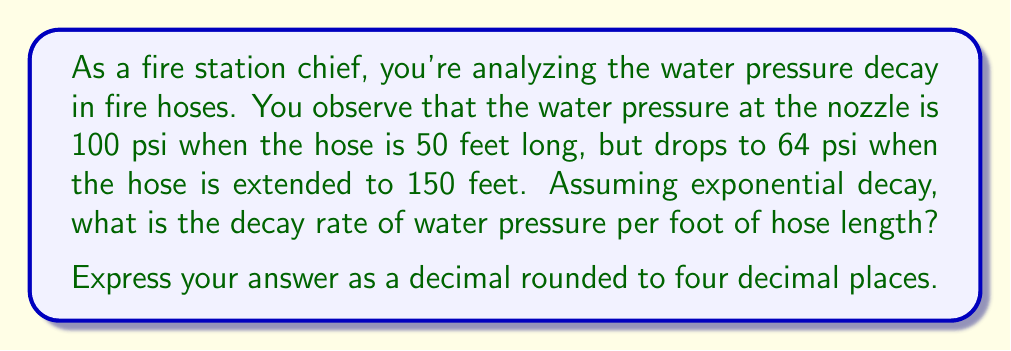Teach me how to tackle this problem. Let's approach this step-by-step using the exponential decay formula:

$$P = P_0 e^{-rx}$$

Where:
$P$ is the final pressure
$P_0$ is the initial pressure
$r$ is the decay rate (what we're solving for)
$x$ is the change in distance

1) We have two data points:
   At 50 feet: $P_1 = 100$ psi
   At 150 feet: $P_2 = 64$ psi

2) We'll use the 50-foot measurement as our initial point. The change in distance is 100 feet (150 - 50).

3) Plugging into our formula:

   $$64 = 100 e^{-r(100)}$$

4) Divide both sides by 100:

   $$0.64 = e^{-100r}$$

5) Take the natural log of both sides:

   $$\ln(0.64) = -100r$$

6) Solve for $r$:

   $$r = -\frac{\ln(0.64)}{100}$$

7) Calculate:

   $$r = -\frac{-0.4462871}{100} = 0.004462871$$

8) Rounding to four decimal places:

   $$r = 0.0045$$

This means the pressure decays by approximately 0.45% per foot of hose length.
Answer: $0.0045$ 